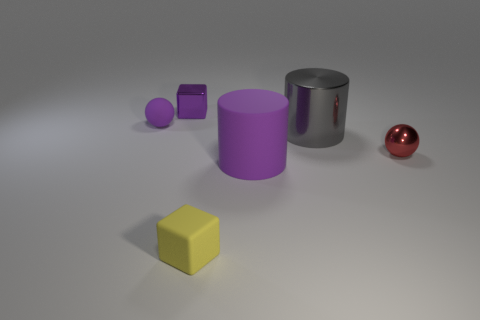How many small brown cylinders are there?
Keep it short and to the point. 0. There is a purple object in front of the red shiny sphere; what shape is it?
Your answer should be very brief. Cylinder. There is a object that is on the left side of the tiny purple object that is right of the small sphere on the left side of the purple cube; what color is it?
Your response must be concise. Purple. What is the shape of the large gray object that is the same material as the red ball?
Your answer should be compact. Cylinder. Is the number of big objects less than the number of tiny matte blocks?
Offer a very short reply. No. Does the purple cylinder have the same material as the large gray cylinder?
Ensure brevity in your answer.  No. How many other objects are there of the same color as the big rubber cylinder?
Offer a very short reply. 2. Is the number of matte spheres greater than the number of tiny yellow metallic balls?
Keep it short and to the point. Yes. There is a red shiny sphere; does it have the same size as the cube that is on the left side of the tiny matte block?
Ensure brevity in your answer.  Yes. The small ball that is in front of the large gray shiny cylinder is what color?
Make the answer very short. Red. 